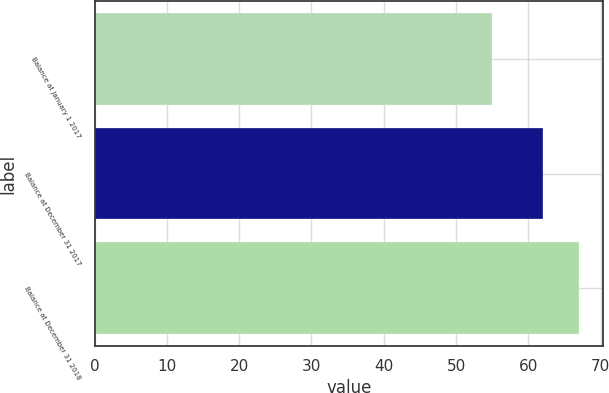Convert chart. <chart><loc_0><loc_0><loc_500><loc_500><bar_chart><fcel>Balance at January 1 2017<fcel>Balance at December 31 2017<fcel>Balance at December 31 2018<nl><fcel>55<fcel>62<fcel>67<nl></chart> 